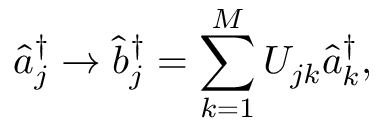<formula> <loc_0><loc_0><loc_500><loc_500>\hat { a } _ { j } ^ { \dag } \rightarrow \hat { b } _ { j } ^ { \dag } = \sum _ { k = 1 } ^ { M } U _ { j k } \hat { a } _ { k } ^ { \dag } ,</formula> 